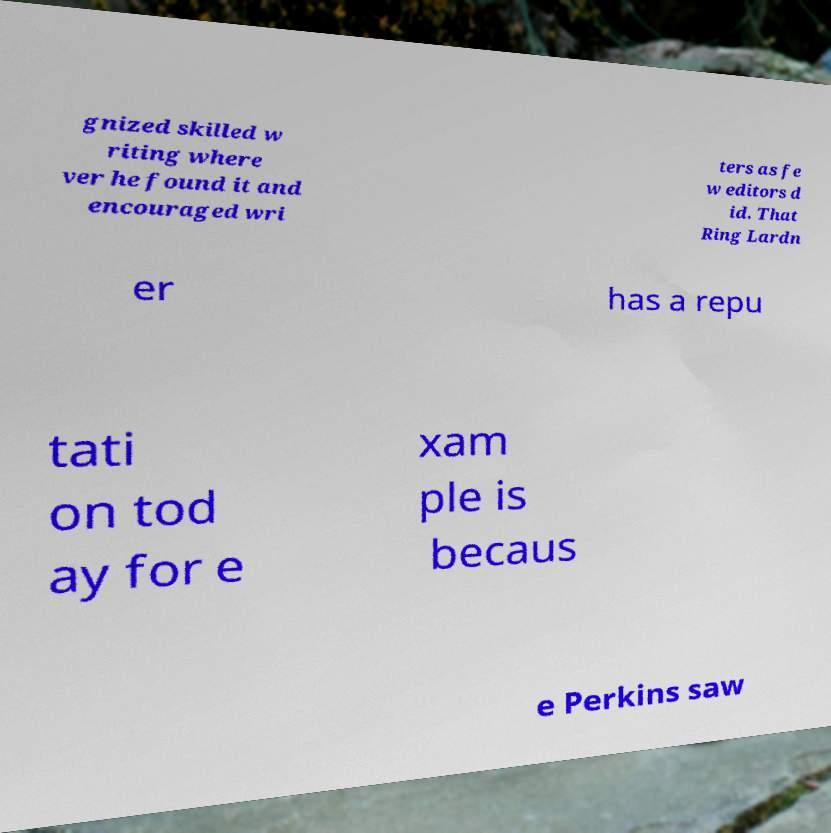There's text embedded in this image that I need extracted. Can you transcribe it verbatim? gnized skilled w riting where ver he found it and encouraged wri ters as fe w editors d id. That Ring Lardn er has a repu tati on tod ay for e xam ple is becaus e Perkins saw 